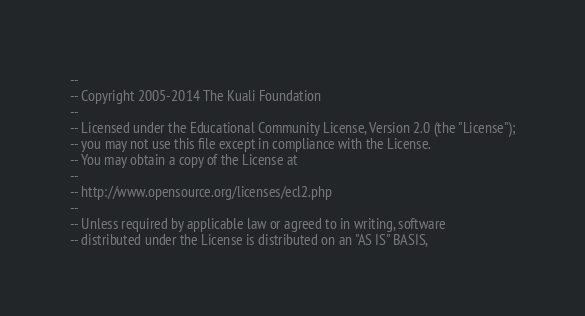Convert code to text. <code><loc_0><loc_0><loc_500><loc_500><_SQL_>--
-- Copyright 2005-2014 The Kuali Foundation
--
-- Licensed under the Educational Community License, Version 2.0 (the "License");
-- you may not use this file except in compliance with the License.
-- You may obtain a copy of the License at
--
-- http://www.opensource.org/licenses/ecl2.php
--
-- Unless required by applicable law or agreed to in writing, software
-- distributed under the License is distributed on an "AS IS" BASIS,</code> 